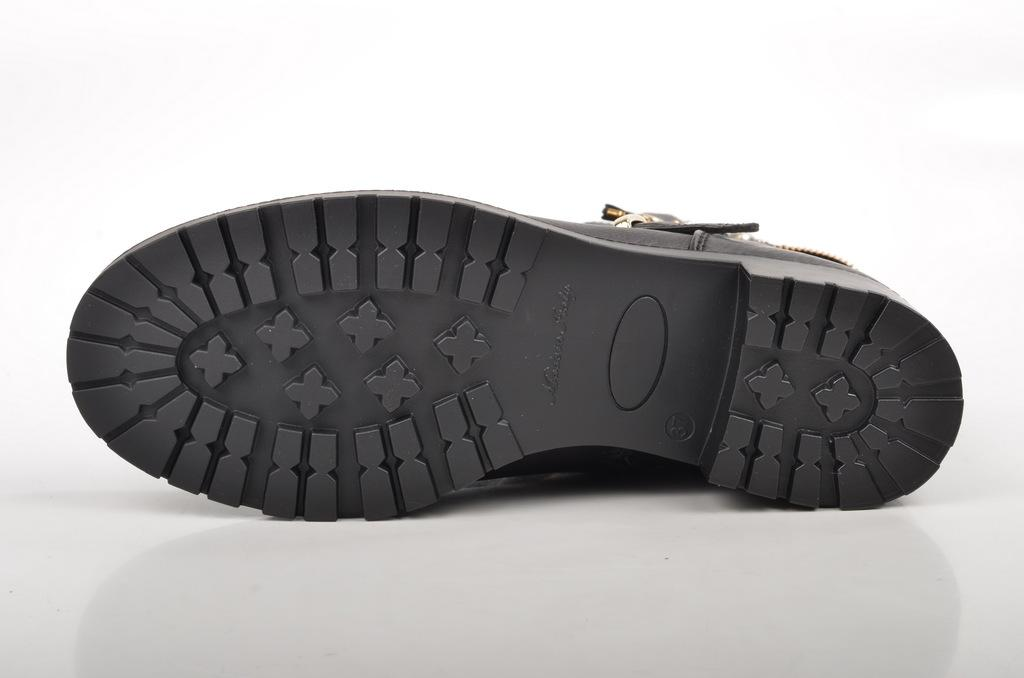What is the main subject in the foreground of the image? There is a shoe sole in the foreground of the image. What is the color of the surface on which the shoe sole is placed? The shoe sole is on a white surface. What type of laborer is using the calculator in the image? There is no laborer or calculator present in the image; it only features a shoe sole on a white surface. 